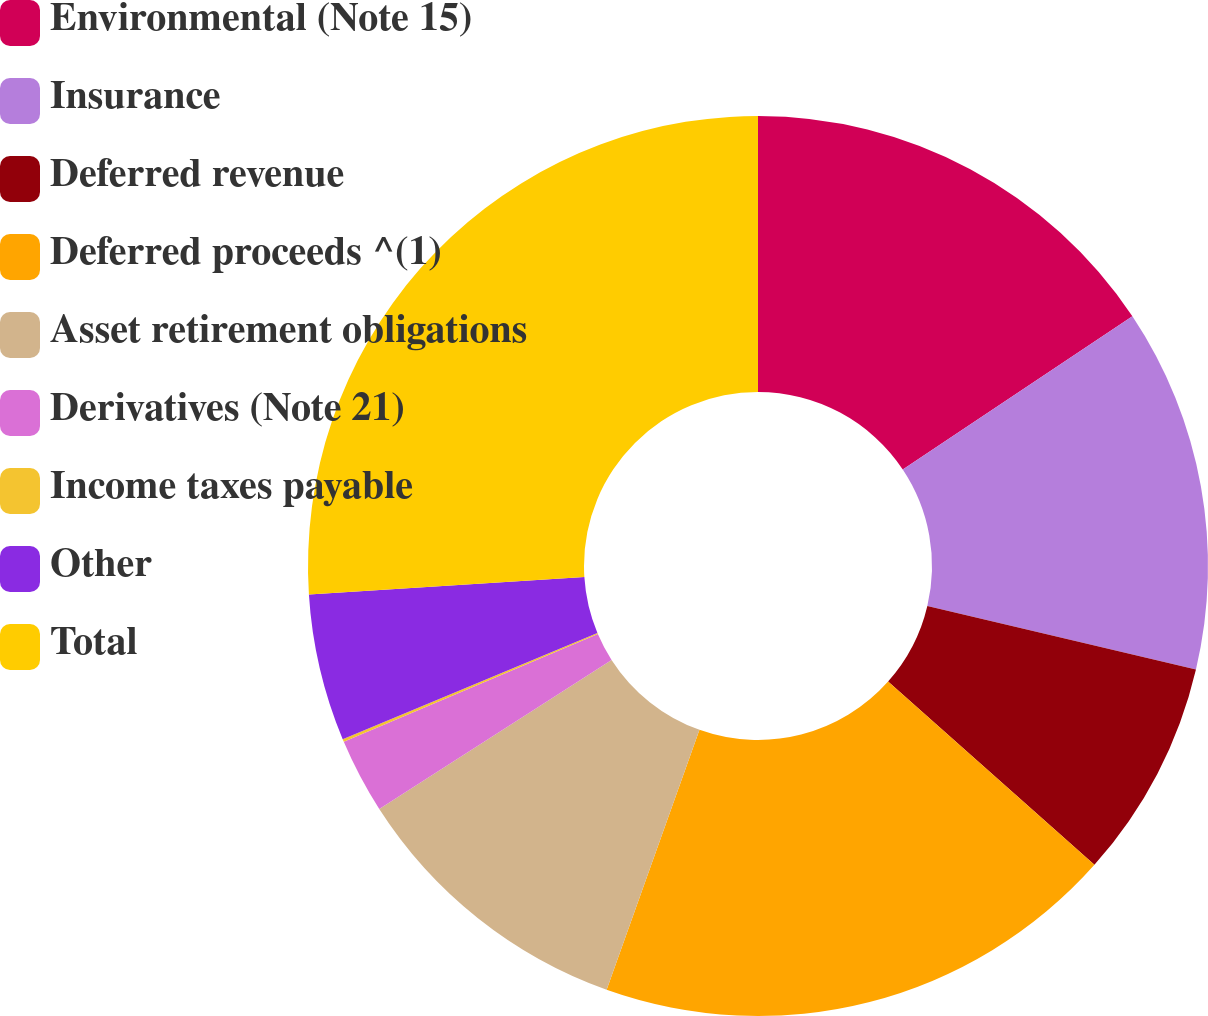<chart> <loc_0><loc_0><loc_500><loc_500><pie_chart><fcel>Environmental (Note 15)<fcel>Insurance<fcel>Deferred revenue<fcel>Deferred proceeds ^(1)<fcel>Asset retirement obligations<fcel>Derivatives (Note 21)<fcel>Income taxes payable<fcel>Other<fcel>Total<nl><fcel>15.64%<fcel>13.05%<fcel>7.87%<fcel>18.9%<fcel>10.46%<fcel>2.69%<fcel>0.1%<fcel>5.28%<fcel>26.01%<nl></chart> 